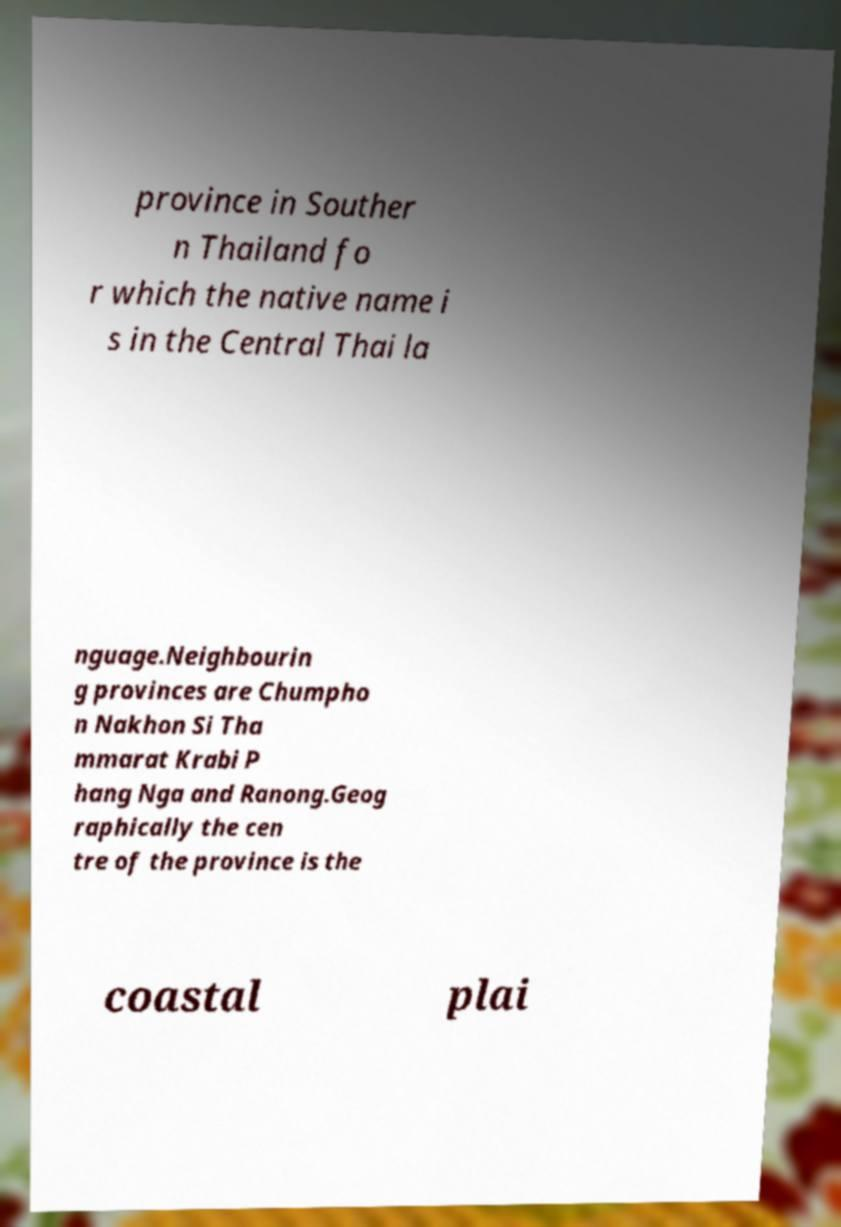Can you read and provide the text displayed in the image?This photo seems to have some interesting text. Can you extract and type it out for me? province in Souther n Thailand fo r which the native name i s in the Central Thai la nguage.Neighbourin g provinces are Chumpho n Nakhon Si Tha mmarat Krabi P hang Nga and Ranong.Geog raphically the cen tre of the province is the coastal plai 